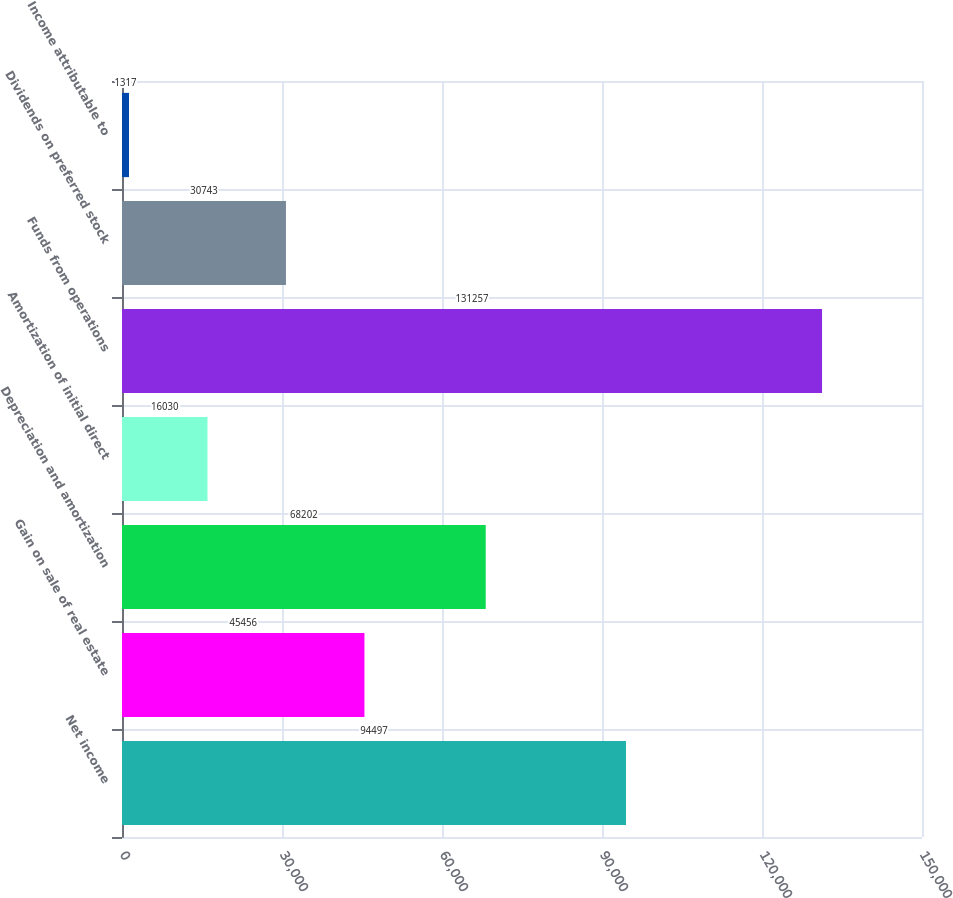Convert chart to OTSL. <chart><loc_0><loc_0><loc_500><loc_500><bar_chart><fcel>Net income<fcel>Gain on sale of real estate<fcel>Depreciation and amortization<fcel>Amortization of initial direct<fcel>Funds from operations<fcel>Dividends on preferred stock<fcel>Income attributable to<nl><fcel>94497<fcel>45456<fcel>68202<fcel>16030<fcel>131257<fcel>30743<fcel>1317<nl></chart> 